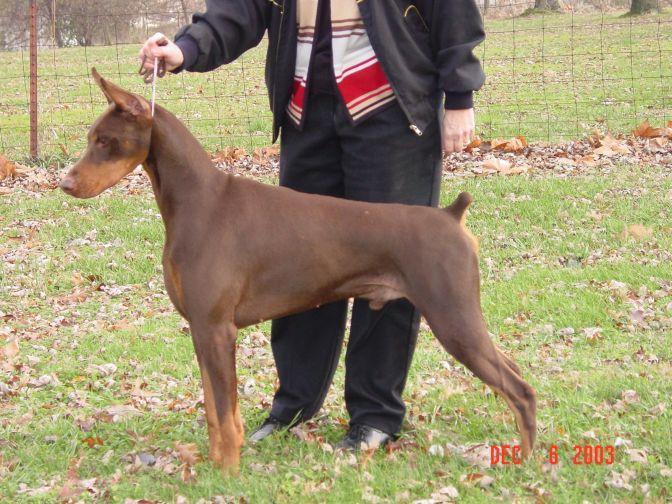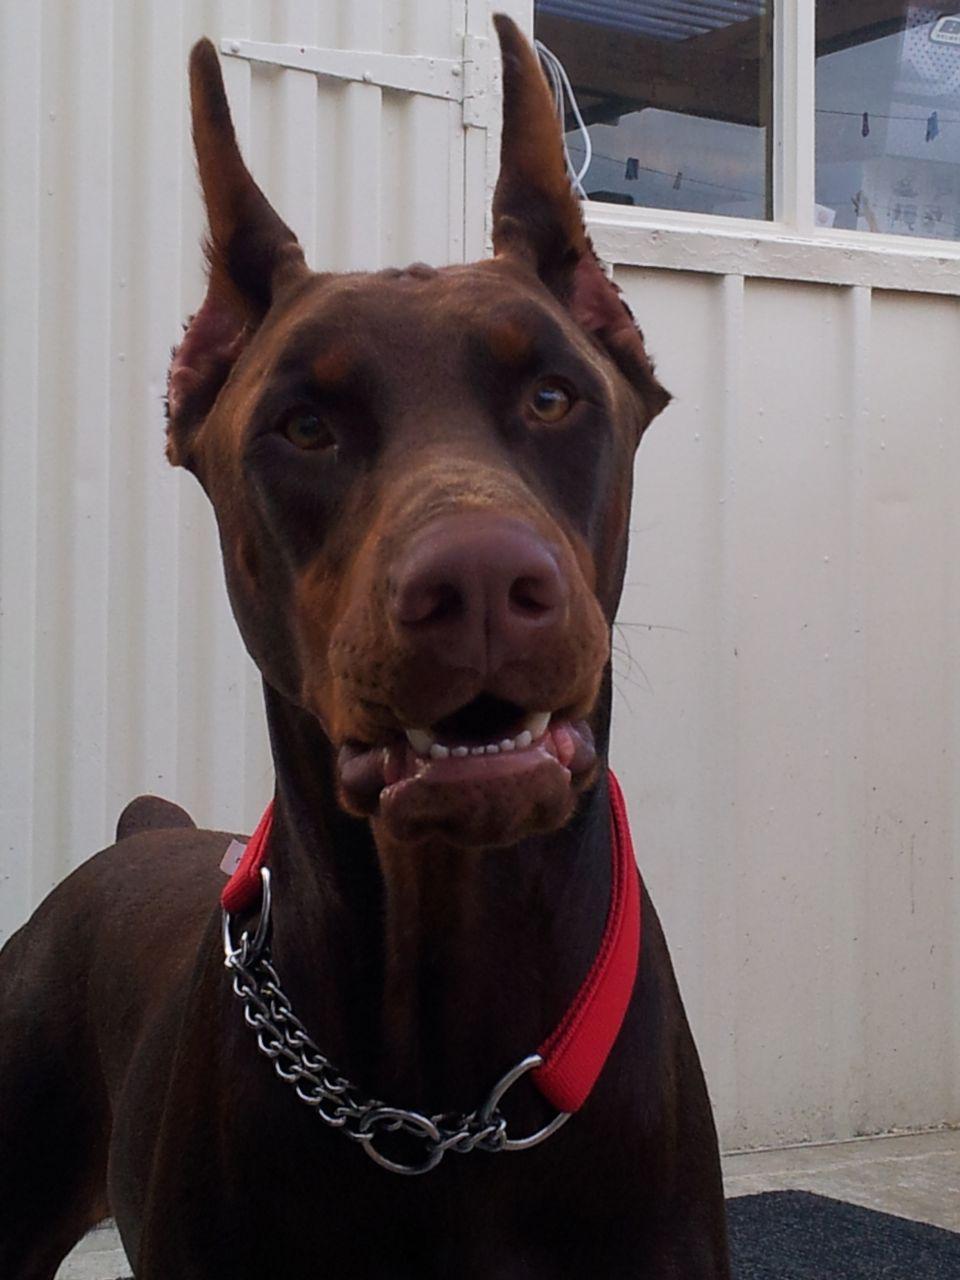The first image is the image on the left, the second image is the image on the right. For the images displayed, is the sentence "A dog facing left and is near a man." factually correct? Answer yes or no. Yes. The first image is the image on the left, the second image is the image on the right. Considering the images on both sides, is "One image contains one pointy-eared doberman wearing a collar that has pale beige fur with mottled tan spots." valid? Answer yes or no. No. 